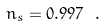<formula> <loc_0><loc_0><loc_500><loc_500>n _ { s } = 0 . 9 9 7 \ .</formula> 